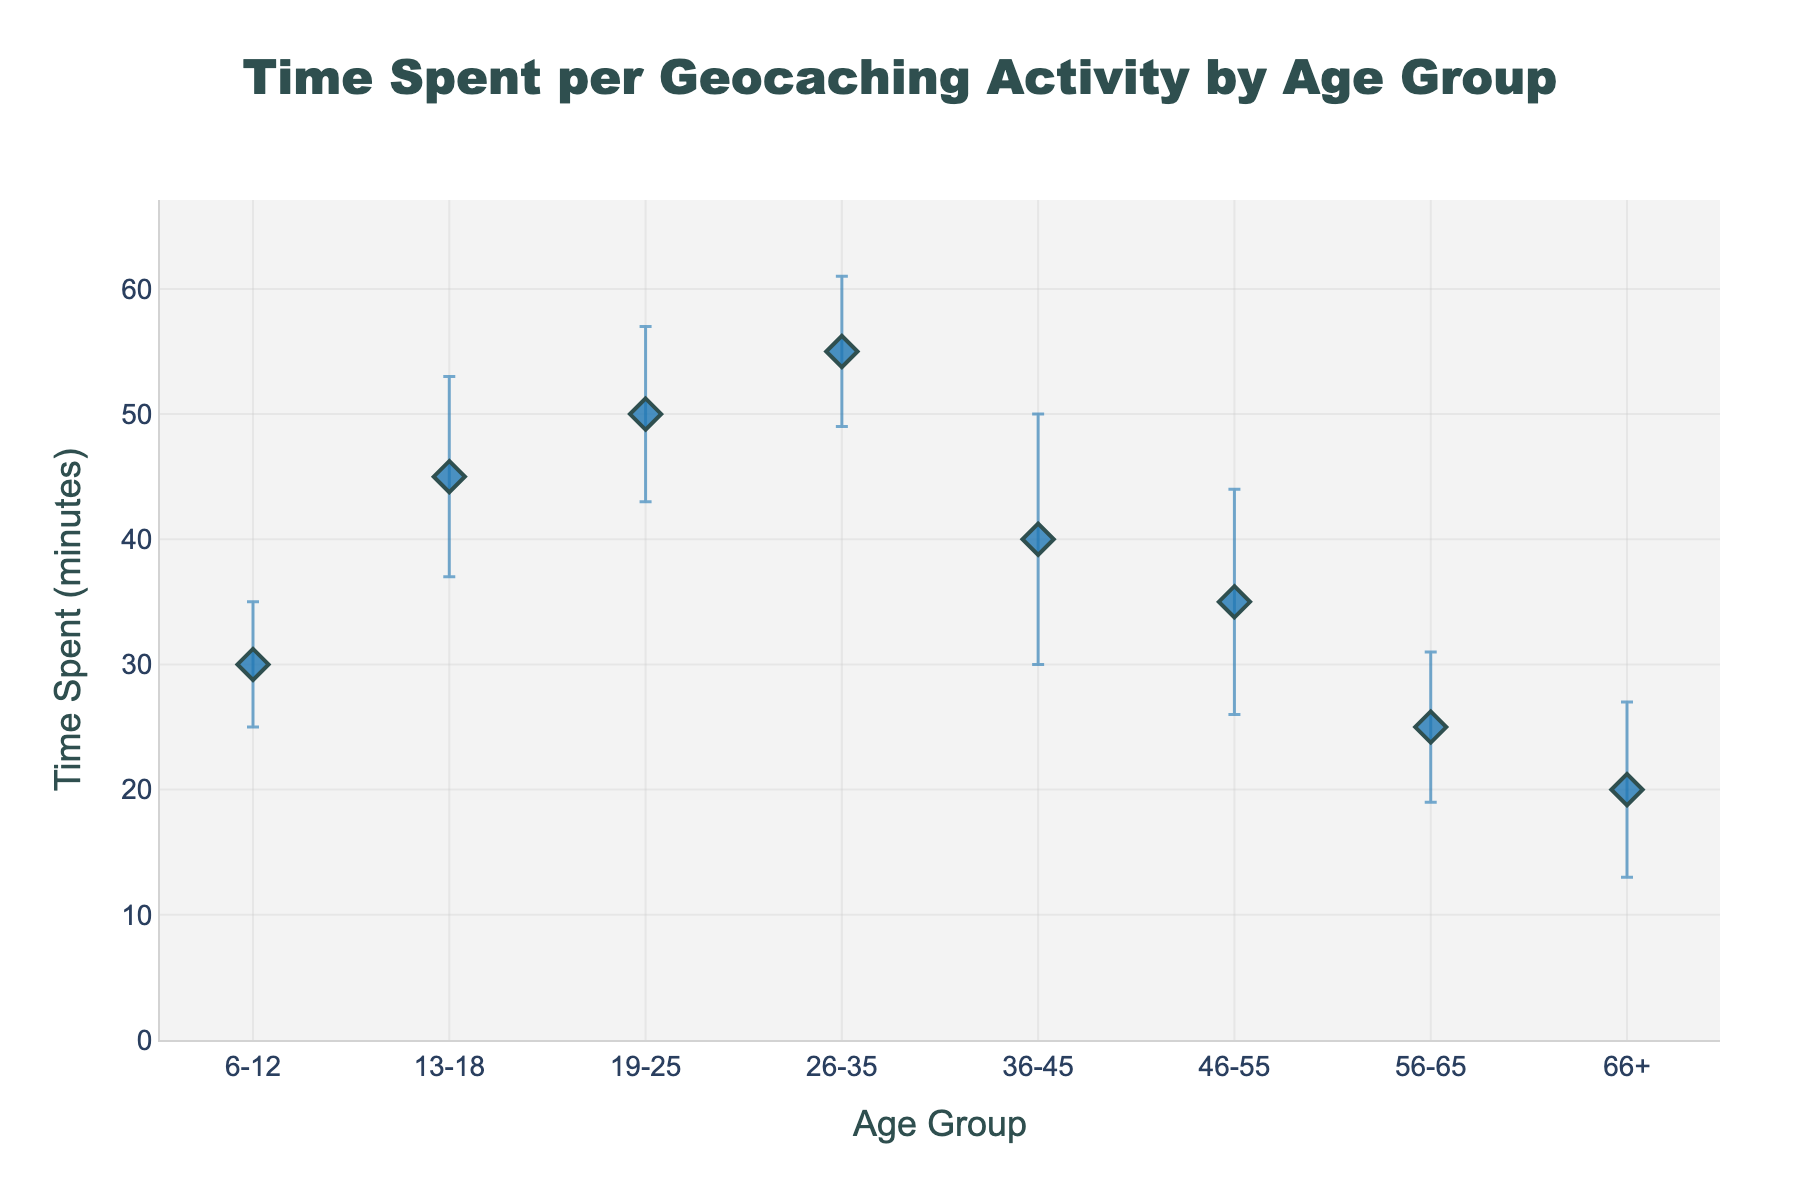What is the title of the figure? The title is displayed at the top center of the plot in larger font size and reads "Time Spent per Geocaching Activity by Age Group".
Answer: Time Spent per Geocaching Activity by Age Group Which age group spends the most time on geocaching activities on average? The mean time spent is highest for the age group 26-35, based on the position of the plot marker on the y-axis.
Answer: 26-35 What's the mean time spent on geocaching activities by the age group 56-65? The marker for the age group 56-65 is located on the y-axis at 25 minutes.
Answer: 25 minutes How does the mean time spent by 13-18-year-olds compare to that of 6-12-year-olds? The mean time spent for 13-18-year-olds is 45 minutes, which is 15 minutes more than the 30 minutes for 6-12-year-olds.
Answer: 13-18-year-olds spend 15 minutes more than 6-12-year-olds What age group has the largest error bar, and what does this indicate? The age group 36-45 has the largest error bar, indicating the highest standard deviation (10 minutes), meaning their geocaching activity times are more spread out.
Answer: 36-45 What is the range of time spent (mean ± standard deviation) for the age group 46-55? The mean time is 35 minutes, with a standard deviation of 9 minutes. The range is (35 - 9) to (35 + 9) minutes, which is 26 to 44 minutes.
Answer: 26 to 44 minutes What is the difference in average time spent between the youngest and oldest age groups? The youngest age group (6-12) spends on average 30 minutes, while the oldest age group (66+) spends 20 minutes. The difference is 30 - 20 = 10 minutes.
Answer: 10 minutes Which age group has the smallest deviation in time spent on geocaching activities? The group 6-12 has the smallest standard deviation of 5 minutes, which is indicated by the shortest error bar.
Answer: 6-12 Rank the age groups in descending order based on their mean time spent on geocaching activities. From the plot, the descending order of mean time spent is: 26-35, 19-25, 13-18, 36-45, 46-55, 6-12, 56-65, 66+.
Answer: 26-35, 19-25, 13-18, 36-45, 46-55, 6-12, 56-65, 66+ What is the overall trend in the mean time spent on geocaching activities as age increases? Generally, the mean time spent decreases as age increases, with the youngest and middle-aged groups spending more time and older groups spending less time.
Answer: Decreases as age increases 